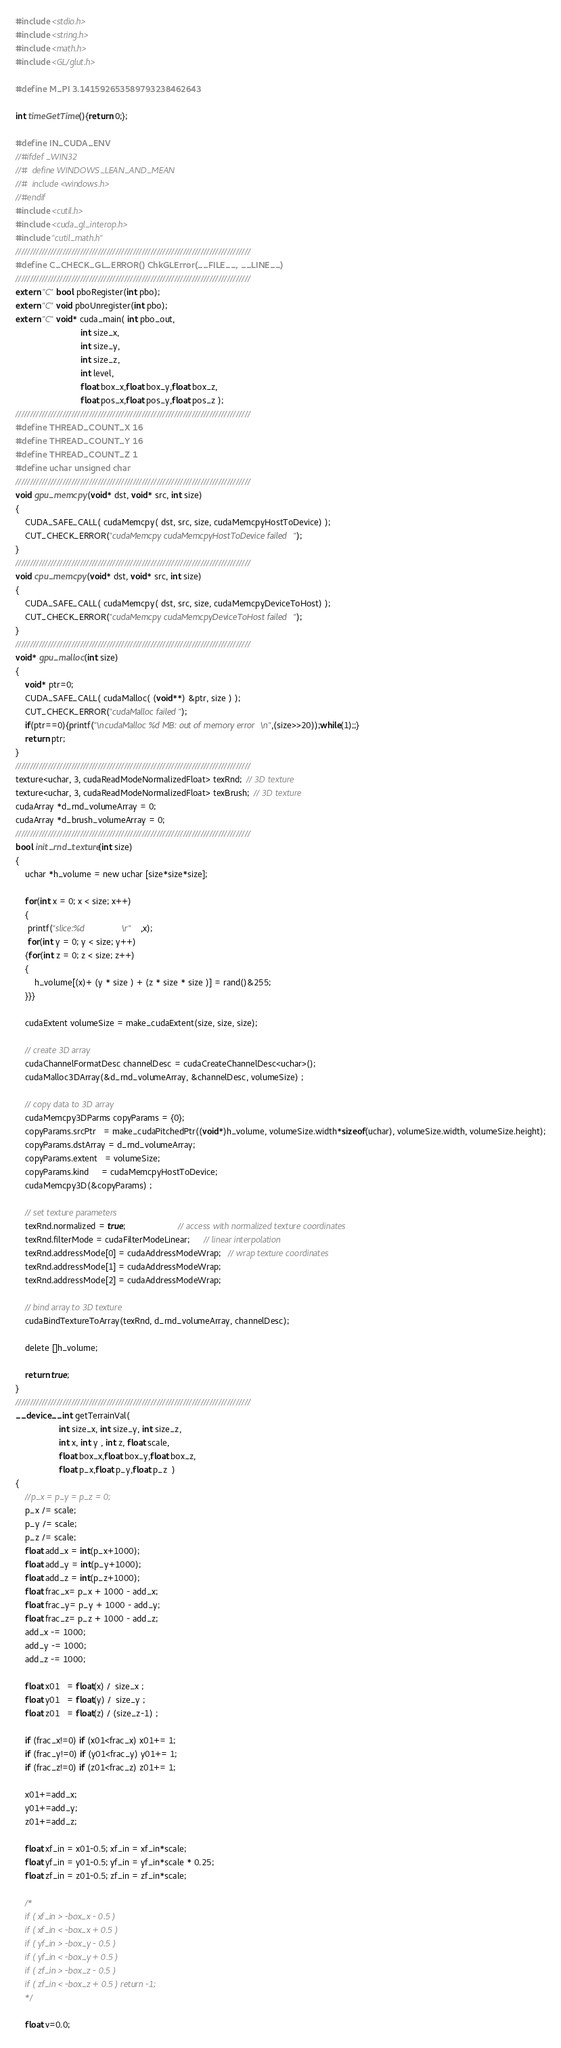Convert code to text. <code><loc_0><loc_0><loc_500><loc_500><_Cuda_>#include <stdio.h>
#include <string.h>
#include <math.h>
#include <GL/glut.h>

#define M_PI 3.141592653589793238462643

int timeGetTime(){return 0;};

#define IN_CUDA_ENV
//#ifdef _WIN32
//#  define WINDOWS_LEAN_AND_MEAN
//#  include <windows.h>
//#endif
#include <cutil.h>
#include <cuda_gl_interop.h>
#include "cutil_math.h"
////////////////////////////////////////////////////////////////////////////////
#define C_CHECK_GL_ERROR() ChkGLError(__FILE__, __LINE__)
////////////////////////////////////////////////////////////////////////////////
extern "C" bool pboRegister(int pbo);
extern "C" void pboUnregister(int pbo);
extern "C" void* cuda_main( int pbo_out, 
						   int size_x, 
						   int size_y, 
						   int size_z, 
						   int level, 
						   float box_x,float box_y,float box_z,
						   float pos_x,float pos_y,float pos_z );
////////////////////////////////////////////////////////////////////////////////
#define THREAD_COUNT_X 16
#define THREAD_COUNT_Y 16
#define THREAD_COUNT_Z 1
#define uchar unsigned char  
////////////////////////////////////////////////////////////////////////////////
void gpu_memcpy(void* dst, void* src, int size)
{
	CUDA_SAFE_CALL( cudaMemcpy( dst, src, size, cudaMemcpyHostToDevice) );
	CUT_CHECK_ERROR("cudaMemcpy cudaMemcpyHostToDevice failed");
}
////////////////////////////////////////////////////////////////////////////////
void cpu_memcpy(void* dst, void* src, int size)
{
	CUDA_SAFE_CALL( cudaMemcpy( dst, src, size, cudaMemcpyDeviceToHost) );
	CUT_CHECK_ERROR("cudaMemcpy cudaMemcpyDeviceToHost failed");
}
////////////////////////////////////////////////////////////////////////////////
void* gpu_malloc(int size)
{
	void* ptr=0;	
	CUDA_SAFE_CALL( cudaMalloc( (void**) &ptr, size ) );
	CUT_CHECK_ERROR("cudaMalloc failed");
	if(ptr==0){printf("\ncudaMalloc %d MB: out of memory error\n",(size>>20));while(1);;}
	return ptr;
}
////////////////////////////////////////////////////////////////////////////////
texture<uchar, 3, cudaReadModeNormalizedFloat> texRnd;  // 3D texture
texture<uchar, 3, cudaReadModeNormalizedFloat> texBrush;  // 3D texture
cudaArray *d_rnd_volumeArray = 0;
cudaArray *d_brush_volumeArray = 0;
////////////////////////////////////////////////////////////////////////////////
bool init_rnd_texture(int size)
{
	uchar *h_volume = new uchar [size*size*size];

	for(int x = 0; x < size; x++)
	{
	 printf("slice:%d               \r"	,x);
	 for(int y = 0; y < size; y++)
	{for(int z = 0; z < size; z++)
	{
		h_volume[(x)+ (y * size ) + (z * size * size )] = rand()&255;
	}}}

	cudaExtent volumeSize = make_cudaExtent(size, size, size);

    // create 3D array
    cudaChannelFormatDesc channelDesc = cudaCreateChannelDesc<uchar>();
    cudaMalloc3DArray(&d_rnd_volumeArray, &channelDesc, volumeSize) ;

    // copy data to 3D array
    cudaMemcpy3DParms copyParams = {0};
    copyParams.srcPtr   = make_cudaPitchedPtr((void*)h_volume, volumeSize.width*sizeof(uchar), volumeSize.width, volumeSize.height);
    copyParams.dstArray = d_rnd_volumeArray;
    copyParams.extent   = volumeSize;
    copyParams.kind     = cudaMemcpyHostToDevice;
    cudaMemcpy3D(&copyParams) ;

    // set texture parameters
    texRnd.normalized = true;                      // access with normalized texture coordinates
    texRnd.filterMode = cudaFilterModeLinear;      // linear interpolation
    texRnd.addressMode[0] = cudaAddressModeWrap;   // wrap texture coordinates
    texRnd.addressMode[1] = cudaAddressModeWrap;
    texRnd.addressMode[2] = cudaAddressModeWrap;

    // bind array to 3D texture
    cudaBindTextureToArray(texRnd, d_rnd_volumeArray, channelDesc);

	delete []h_volume;

	return true;
}
////////////////////////////////////////////////////////////////////////////////
__device__ int getTerrainVal( 
				  int size_x, int size_y, int size_z, 
				  int x, int y , int z, float scale,
				  float box_x,float box_y,float box_z,
				  float p_x,float p_y,float p_z  )
{
	//p_x = p_y = p_z = 0;
	p_x /= scale;
	p_y /= scale;
	p_z /= scale;
	float add_x = int(p_x+1000);
	float add_y = int(p_y+1000);
	float add_z = int(p_z+1000);
	float frac_x= p_x + 1000 - add_x;
	float frac_y= p_y + 1000 - add_y;
	float frac_z= p_z + 1000 - add_z;
	add_x -= 1000;
	add_y -= 1000;
	add_z -= 1000;

	float x01   = float(x) /  size_x ;
	float y01   = float(y) /  size_y ;
	float z01   = float(z) / (size_z-1) ;

	if (frac_x!=0) if (x01<frac_x) x01+= 1;
	if (frac_y!=0) if (y01<frac_y) y01+= 1;
	if (frac_z!=0) if (z01<frac_z) z01+= 1;

	x01+=add_x;
	y01+=add_y;
	z01+=add_z;

	float xf_in = x01-0.5; xf_in = xf_in*scale;
	float yf_in = y01-0.5; yf_in = yf_in*scale * 0.25;
	float zf_in = z01-0.5; zf_in = zf_in*scale;

	/*
	if ( xf_in > -box_x - 0.5 )
	if ( xf_in < -box_x + 0.5 ) 
	if ( yf_in > -box_y - 0.5 )
	if ( yf_in < -box_y + 0.5 ) 
	if ( zf_in > -box_z - 0.5 )
	if ( zf_in < -box_z + 0.5 ) return -1;
	*/
							   		
	float v=0.0;
</code> 